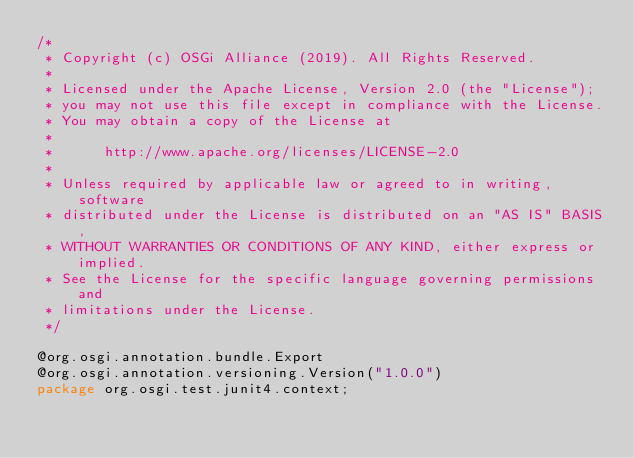<code> <loc_0><loc_0><loc_500><loc_500><_Java_>/*
 * Copyright (c) OSGi Alliance (2019). All Rights Reserved.
 *
 * Licensed under the Apache License, Version 2.0 (the "License");
 * you may not use this file except in compliance with the License.
 * You may obtain a copy of the License at
 *
 *      http://www.apache.org/licenses/LICENSE-2.0
 *
 * Unless required by applicable law or agreed to in writing, software
 * distributed under the License is distributed on an "AS IS" BASIS,
 * WITHOUT WARRANTIES OR CONDITIONS OF ANY KIND, either express or implied.
 * See the License for the specific language governing permissions and
 * limitations under the License.
 */

@org.osgi.annotation.bundle.Export
@org.osgi.annotation.versioning.Version("1.0.0")
package org.osgi.test.junit4.context;
</code> 